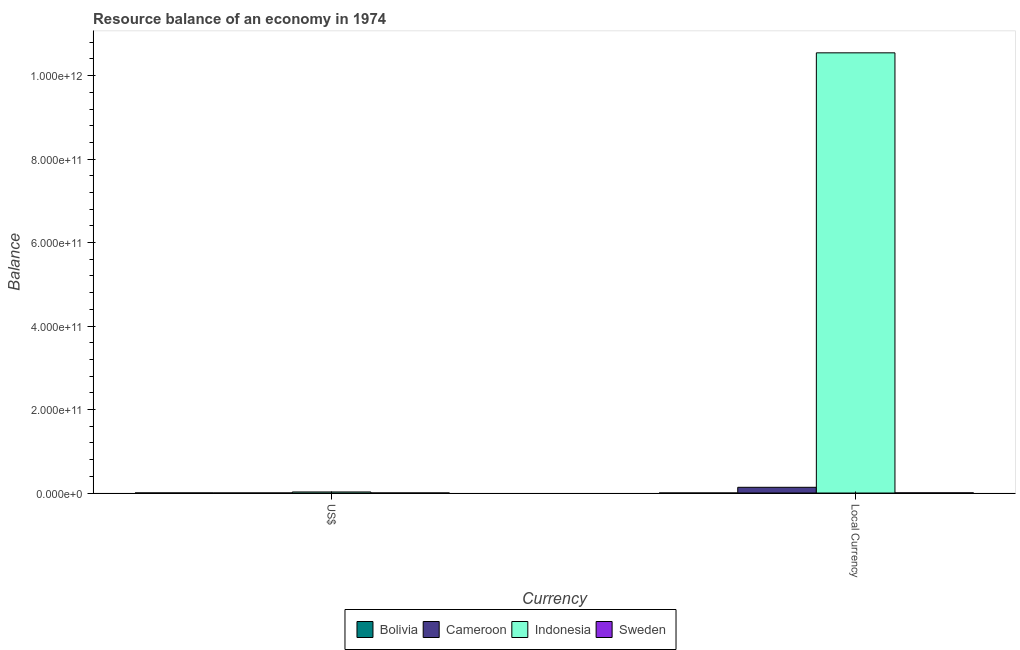How many different coloured bars are there?
Your response must be concise. 4. Are the number of bars on each tick of the X-axis equal?
Your answer should be very brief. Yes. How many bars are there on the 2nd tick from the left?
Provide a succinct answer. 4. How many bars are there on the 1st tick from the right?
Your answer should be very brief. 4. What is the label of the 1st group of bars from the left?
Offer a terse response. US$. What is the resource balance in constant us$ in Cameroon?
Your response must be concise. 1.37e+1. Across all countries, what is the maximum resource balance in constant us$?
Keep it short and to the point. 1.05e+12. Across all countries, what is the minimum resource balance in us$?
Give a very brief answer. 5.95e+07. What is the total resource balance in constant us$ in the graph?
Offer a terse response. 1.07e+12. What is the difference between the resource balance in us$ in Sweden and that in Cameroon?
Make the answer very short. 1.87e+07. What is the difference between the resource balance in constant us$ in Sweden and the resource balance in us$ in Indonesia?
Give a very brief answer. -2.19e+09. What is the average resource balance in constant us$ per country?
Your answer should be very brief. 2.67e+11. What is the difference between the resource balance in us$ and resource balance in constant us$ in Sweden?
Make the answer very short. -2.69e+08. What is the ratio of the resource balance in constant us$ in Cameroon to that in Bolivia?
Keep it short and to the point. 3.84e+06. In how many countries, is the resource balance in us$ greater than the average resource balance in us$ taken over all countries?
Give a very brief answer. 1. What does the 2nd bar from the left in Local Currency represents?
Provide a succinct answer. Cameroon. What does the 3rd bar from the right in US$ represents?
Your answer should be very brief. Cameroon. Are all the bars in the graph horizontal?
Keep it short and to the point. No. What is the difference between two consecutive major ticks on the Y-axis?
Give a very brief answer. 2.00e+11. Does the graph contain grids?
Give a very brief answer. No. What is the title of the graph?
Keep it short and to the point. Resource balance of an economy in 1974. Does "Morocco" appear as one of the legend labels in the graph?
Provide a short and direct response. No. What is the label or title of the X-axis?
Your response must be concise. Currency. What is the label or title of the Y-axis?
Make the answer very short. Balance. What is the Balance in Bolivia in US$?
Make the answer very short. 1.78e+08. What is the Balance of Cameroon in US$?
Your answer should be compact. 5.95e+07. What is the Balance of Indonesia in US$?
Offer a terse response. 2.54e+09. What is the Balance of Sweden in US$?
Your answer should be very brief. 7.82e+07. What is the Balance in Bolivia in Local Currency?
Offer a terse response. 3570. What is the Balance in Cameroon in Local Currency?
Offer a very short reply. 1.37e+1. What is the Balance of Indonesia in Local Currency?
Give a very brief answer. 1.05e+12. What is the Balance of Sweden in Local Currency?
Offer a very short reply. 3.47e+08. Across all Currency, what is the maximum Balance in Bolivia?
Ensure brevity in your answer.  1.78e+08. Across all Currency, what is the maximum Balance in Cameroon?
Your answer should be compact. 1.37e+1. Across all Currency, what is the maximum Balance of Indonesia?
Your answer should be compact. 1.05e+12. Across all Currency, what is the maximum Balance in Sweden?
Provide a succinct answer. 3.47e+08. Across all Currency, what is the minimum Balance in Bolivia?
Your answer should be very brief. 3570. Across all Currency, what is the minimum Balance in Cameroon?
Your response must be concise. 5.95e+07. Across all Currency, what is the minimum Balance of Indonesia?
Your answer should be very brief. 2.54e+09. Across all Currency, what is the minimum Balance in Sweden?
Offer a terse response. 7.82e+07. What is the total Balance of Bolivia in the graph?
Your answer should be very brief. 1.78e+08. What is the total Balance in Cameroon in the graph?
Offer a terse response. 1.38e+1. What is the total Balance in Indonesia in the graph?
Ensure brevity in your answer.  1.06e+12. What is the total Balance in Sweden in the graph?
Provide a succinct answer. 4.25e+08. What is the difference between the Balance in Bolivia in US$ and that in Local Currency?
Give a very brief answer. 1.78e+08. What is the difference between the Balance in Cameroon in US$ and that in Local Currency?
Keep it short and to the point. -1.36e+1. What is the difference between the Balance of Indonesia in US$ and that in Local Currency?
Your answer should be compact. -1.05e+12. What is the difference between the Balance in Sweden in US$ and that in Local Currency?
Provide a succinct answer. -2.69e+08. What is the difference between the Balance of Bolivia in US$ and the Balance of Cameroon in Local Currency?
Make the answer very short. -1.35e+1. What is the difference between the Balance in Bolivia in US$ and the Balance in Indonesia in Local Currency?
Offer a terse response. -1.05e+12. What is the difference between the Balance of Bolivia in US$ and the Balance of Sweden in Local Currency?
Your answer should be very brief. -1.69e+08. What is the difference between the Balance in Cameroon in US$ and the Balance in Indonesia in Local Currency?
Your answer should be very brief. -1.05e+12. What is the difference between the Balance of Cameroon in US$ and the Balance of Sweden in Local Currency?
Provide a short and direct response. -2.88e+08. What is the difference between the Balance of Indonesia in US$ and the Balance of Sweden in Local Currency?
Give a very brief answer. 2.19e+09. What is the average Balance in Bolivia per Currency?
Provide a succinct answer. 8.92e+07. What is the average Balance in Cameroon per Currency?
Offer a very short reply. 6.88e+09. What is the average Balance of Indonesia per Currency?
Offer a terse response. 5.29e+11. What is the average Balance in Sweden per Currency?
Ensure brevity in your answer.  2.13e+08. What is the difference between the Balance in Bolivia and Balance in Cameroon in US$?
Ensure brevity in your answer.  1.19e+08. What is the difference between the Balance in Bolivia and Balance in Indonesia in US$?
Your answer should be very brief. -2.36e+09. What is the difference between the Balance in Bolivia and Balance in Sweden in US$?
Make the answer very short. 1.00e+08. What is the difference between the Balance of Cameroon and Balance of Indonesia in US$?
Provide a succinct answer. -2.48e+09. What is the difference between the Balance of Cameroon and Balance of Sweden in US$?
Give a very brief answer. -1.87e+07. What is the difference between the Balance in Indonesia and Balance in Sweden in US$?
Give a very brief answer. 2.46e+09. What is the difference between the Balance in Bolivia and Balance in Cameroon in Local Currency?
Ensure brevity in your answer.  -1.37e+1. What is the difference between the Balance of Bolivia and Balance of Indonesia in Local Currency?
Provide a short and direct response. -1.05e+12. What is the difference between the Balance of Bolivia and Balance of Sweden in Local Currency?
Give a very brief answer. -3.47e+08. What is the difference between the Balance in Cameroon and Balance in Indonesia in Local Currency?
Ensure brevity in your answer.  -1.04e+12. What is the difference between the Balance in Cameroon and Balance in Sweden in Local Currency?
Your answer should be compact. 1.34e+1. What is the difference between the Balance of Indonesia and Balance of Sweden in Local Currency?
Your response must be concise. 1.05e+12. What is the ratio of the Balance of Bolivia in US$ to that in Local Currency?
Ensure brevity in your answer.  5.00e+04. What is the ratio of the Balance in Cameroon in US$ to that in Local Currency?
Your answer should be very brief. 0. What is the ratio of the Balance in Indonesia in US$ to that in Local Currency?
Offer a terse response. 0. What is the ratio of the Balance of Sweden in US$ to that in Local Currency?
Keep it short and to the point. 0.23. What is the difference between the highest and the second highest Balance of Bolivia?
Give a very brief answer. 1.78e+08. What is the difference between the highest and the second highest Balance in Cameroon?
Your answer should be very brief. 1.36e+1. What is the difference between the highest and the second highest Balance of Indonesia?
Your response must be concise. 1.05e+12. What is the difference between the highest and the second highest Balance in Sweden?
Ensure brevity in your answer.  2.69e+08. What is the difference between the highest and the lowest Balance of Bolivia?
Your response must be concise. 1.78e+08. What is the difference between the highest and the lowest Balance of Cameroon?
Provide a succinct answer. 1.36e+1. What is the difference between the highest and the lowest Balance of Indonesia?
Give a very brief answer. 1.05e+12. What is the difference between the highest and the lowest Balance in Sweden?
Give a very brief answer. 2.69e+08. 